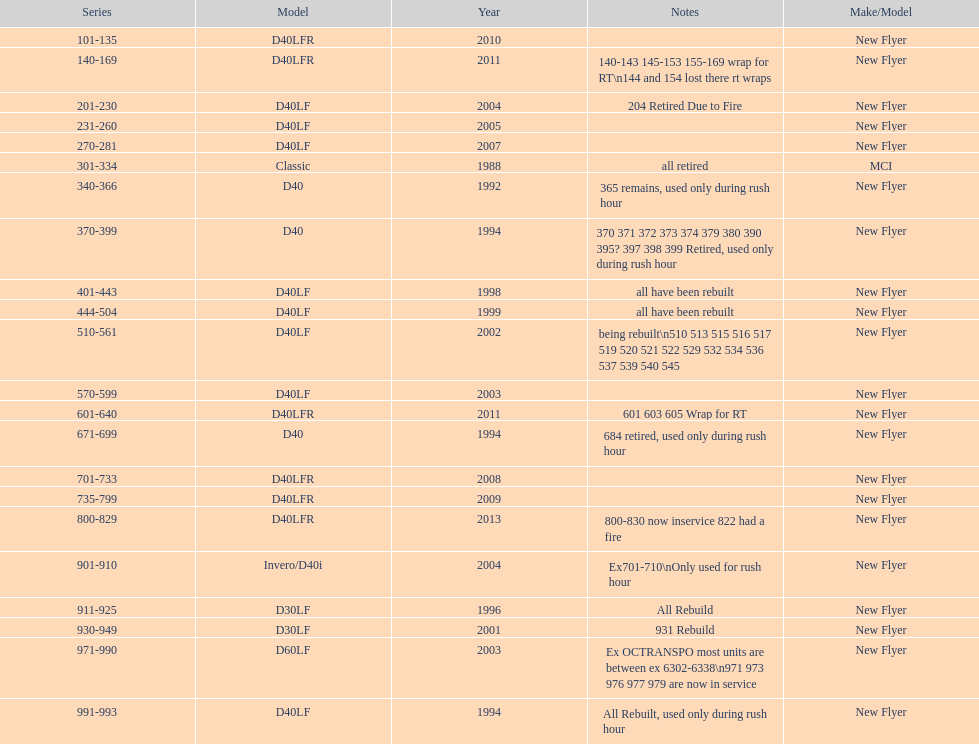Which buses are the newest in the current fleet? 800-829. 